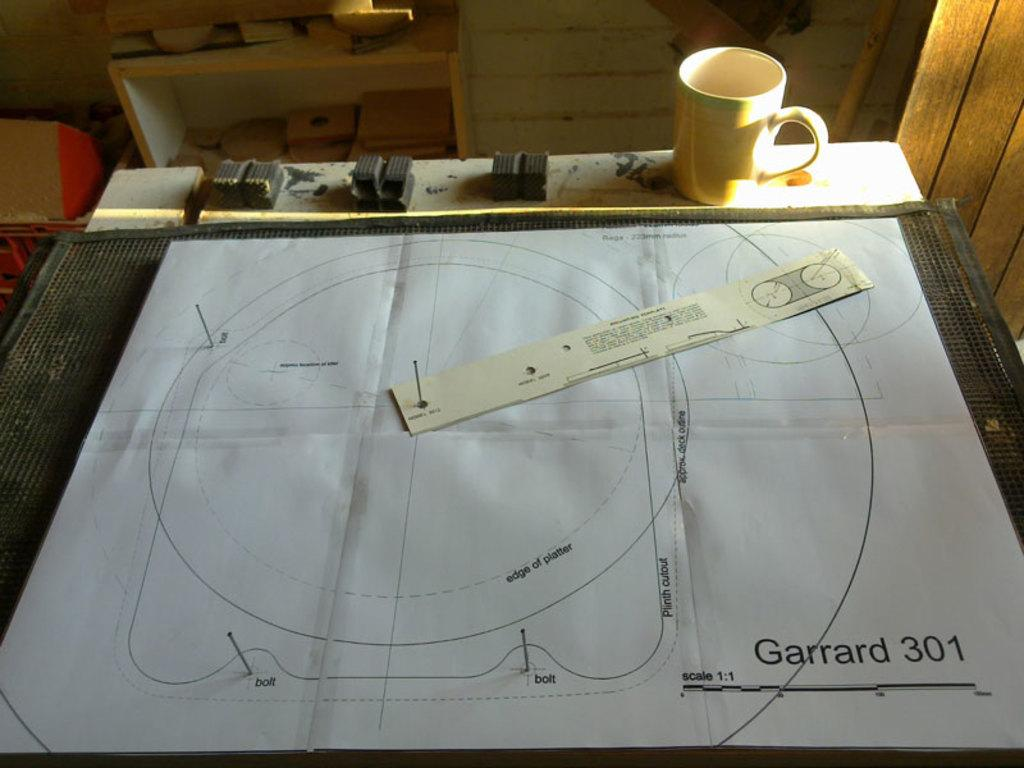<image>
Relay a brief, clear account of the picture shown. a page on a table that says 'garrard 301' 